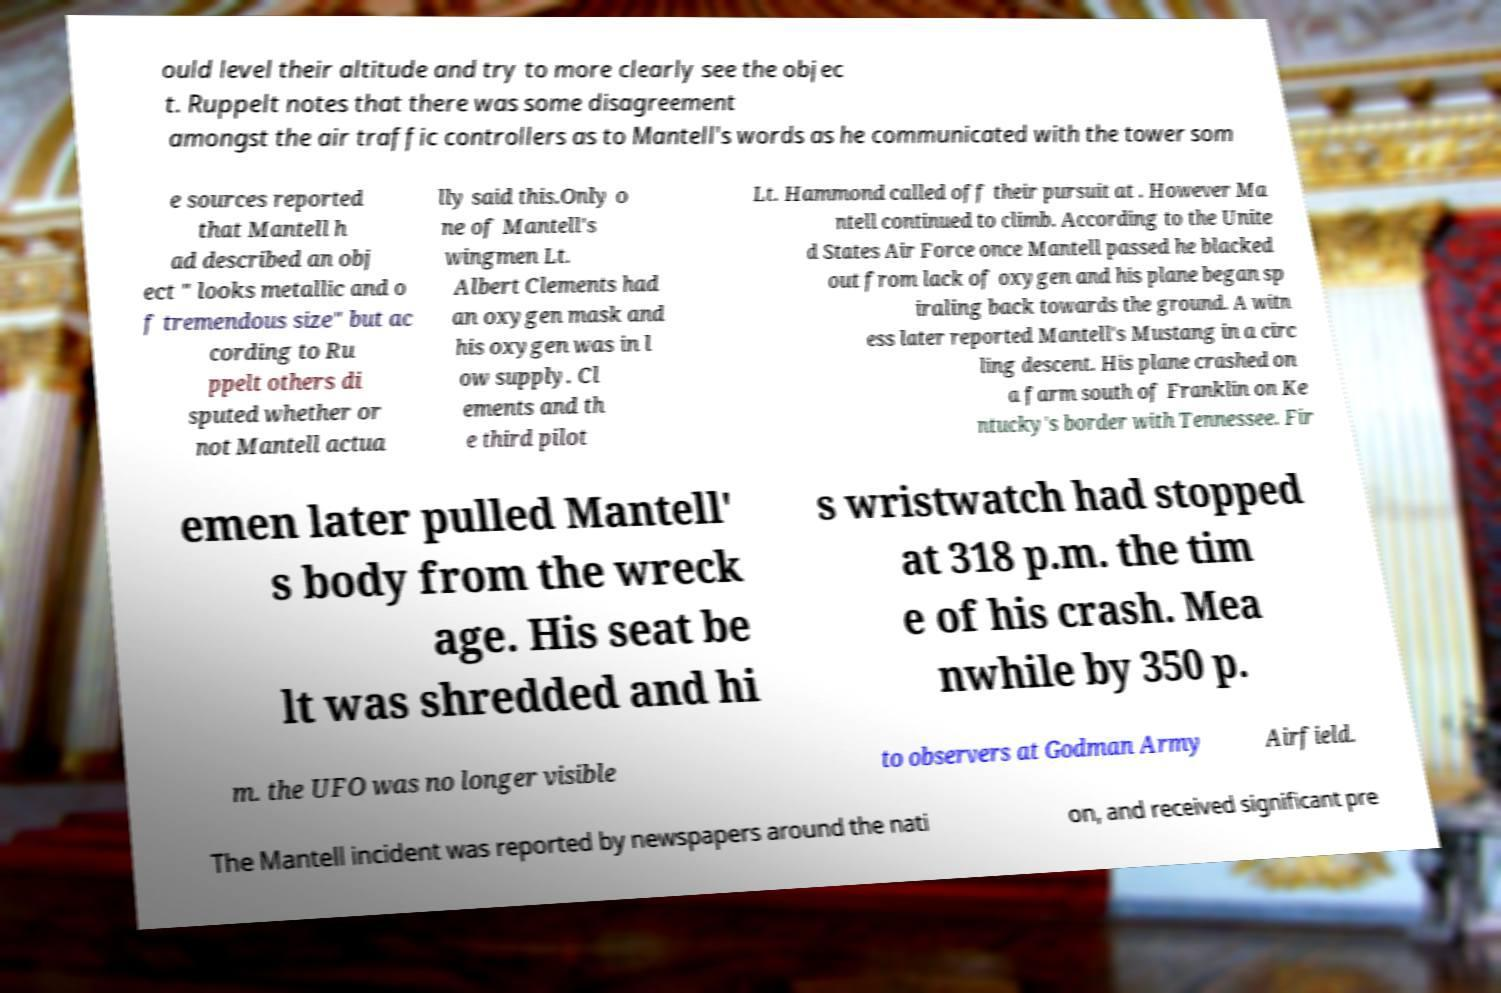For documentation purposes, I need the text within this image transcribed. Could you provide that? ould level their altitude and try to more clearly see the objec t. Ruppelt notes that there was some disagreement amongst the air traffic controllers as to Mantell's words as he communicated with the tower som e sources reported that Mantell h ad described an obj ect " looks metallic and o f tremendous size" but ac cording to Ru ppelt others di sputed whether or not Mantell actua lly said this.Only o ne of Mantell's wingmen Lt. Albert Clements had an oxygen mask and his oxygen was in l ow supply. Cl ements and th e third pilot Lt. Hammond called off their pursuit at . However Ma ntell continued to climb. According to the Unite d States Air Force once Mantell passed he blacked out from lack of oxygen and his plane began sp iraling back towards the ground. A witn ess later reported Mantell's Mustang in a circ ling descent. His plane crashed on a farm south of Franklin on Ke ntucky's border with Tennessee. Fir emen later pulled Mantell' s body from the wreck age. His seat be lt was shredded and hi s wristwatch had stopped at 318 p.m. the tim e of his crash. Mea nwhile by 350 p. m. the UFO was no longer visible to observers at Godman Army Airfield. The Mantell incident was reported by newspapers around the nati on, and received significant pre 